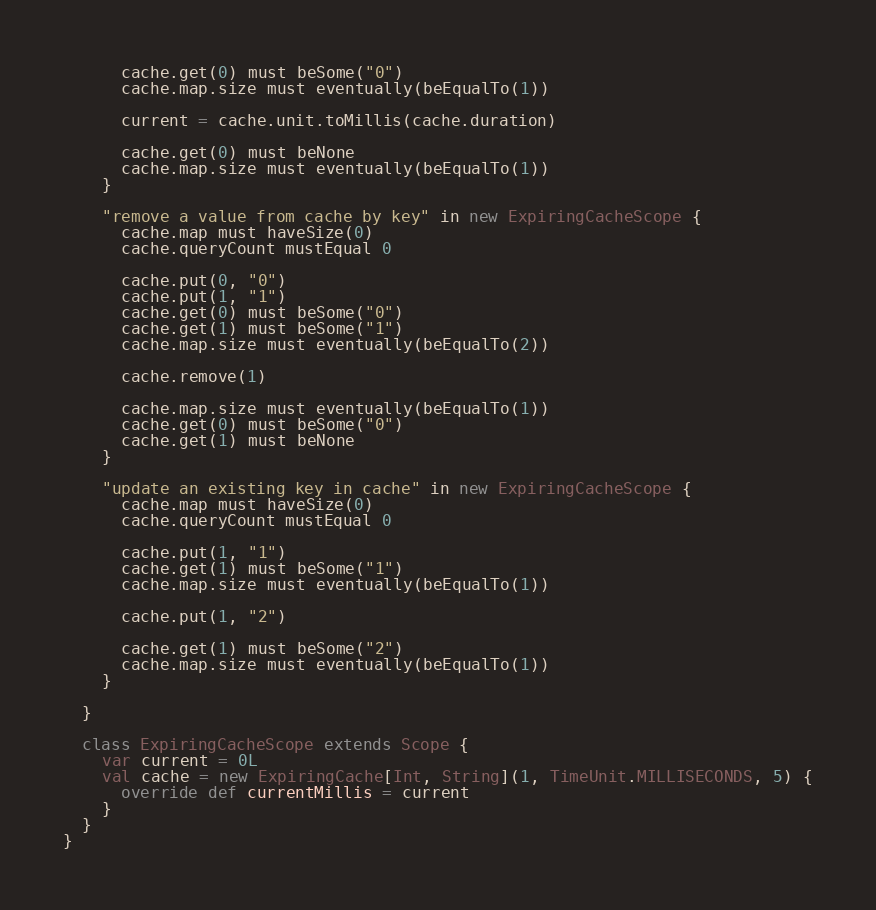<code> <loc_0><loc_0><loc_500><loc_500><_Scala_>      cache.get(0) must beSome("0")
      cache.map.size must eventually(beEqualTo(1))

      current = cache.unit.toMillis(cache.duration)

      cache.get(0) must beNone
      cache.map.size must eventually(beEqualTo(1))
    }

    "remove a value from cache by key" in new ExpiringCacheScope {
      cache.map must haveSize(0)
      cache.queryCount mustEqual 0

      cache.put(0, "0")
      cache.put(1, "1")
      cache.get(0) must beSome("0")
      cache.get(1) must beSome("1")
      cache.map.size must eventually(beEqualTo(2))

      cache.remove(1)

      cache.map.size must eventually(beEqualTo(1))
      cache.get(0) must beSome("0")
      cache.get(1) must beNone
    }

    "update an existing key in cache" in new ExpiringCacheScope {
      cache.map must haveSize(0)
      cache.queryCount mustEqual 0

      cache.put(1, "1")
      cache.get(1) must beSome("1")
      cache.map.size must eventually(beEqualTo(1))

      cache.put(1, "2")

      cache.get(1) must beSome("2")
      cache.map.size must eventually(beEqualTo(1))
    }

  }

  class ExpiringCacheScope extends Scope {
    var current = 0L
    val cache = new ExpiringCache[Int, String](1, TimeUnit.MILLISECONDS, 5) {
      override def currentMillis = current
    }
  }
}
</code> 